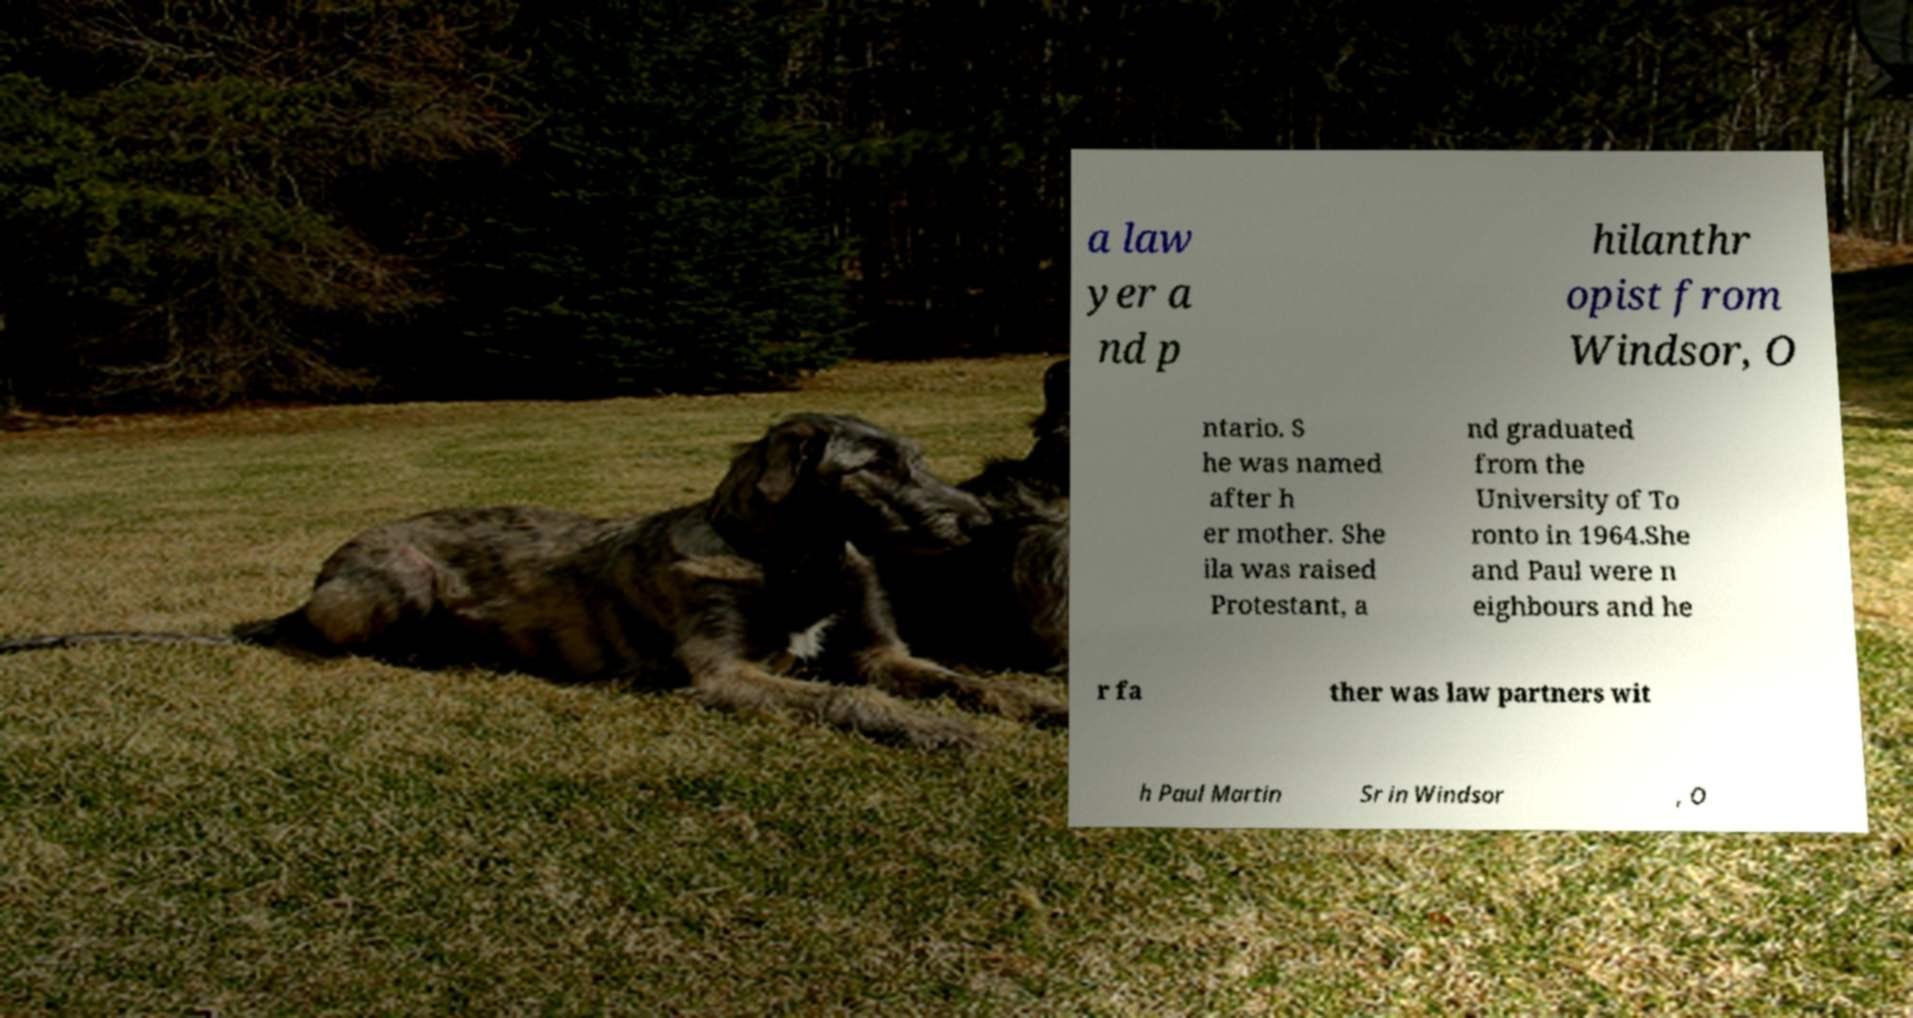Can you accurately transcribe the text from the provided image for me? a law yer a nd p hilanthr opist from Windsor, O ntario. S he was named after h er mother. She ila was raised Protestant, a nd graduated from the University of To ronto in 1964.She and Paul were n eighbours and he r fa ther was law partners wit h Paul Martin Sr in Windsor , O 